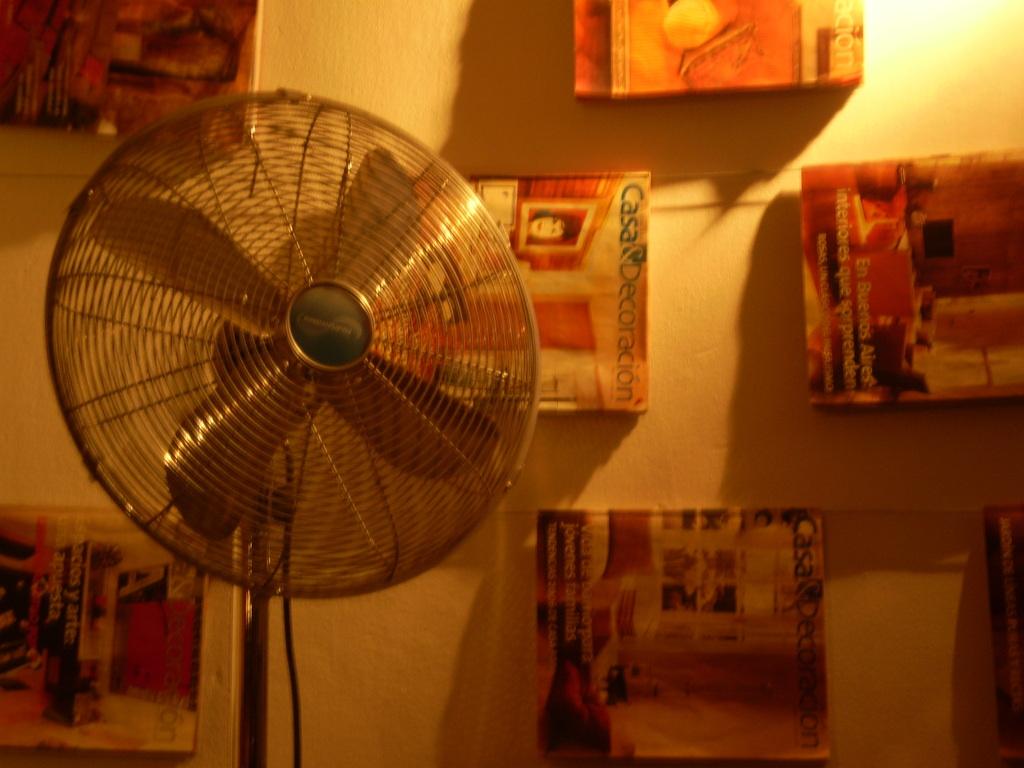What magazine is hanging behind the fan?
Provide a short and direct response. Casa decoracion. 